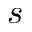Convert formula to latex. <formula><loc_0><loc_0><loc_500><loc_500>s</formula> 